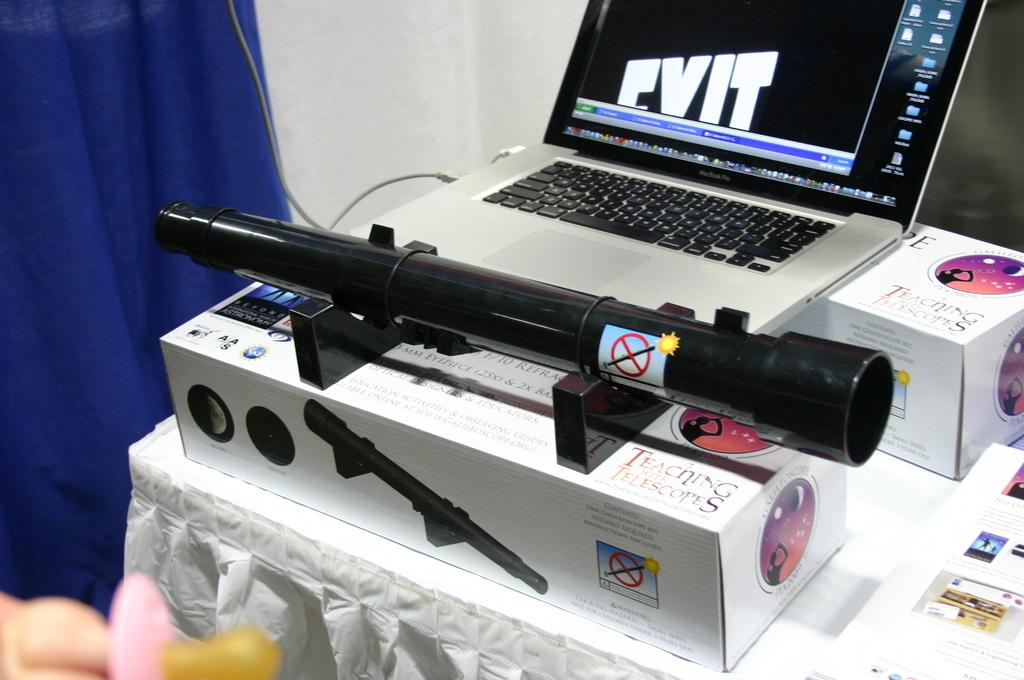<image>
Offer a succinct explanation of the picture presented. A scope on a box that reads Teaching with Telescopes. 